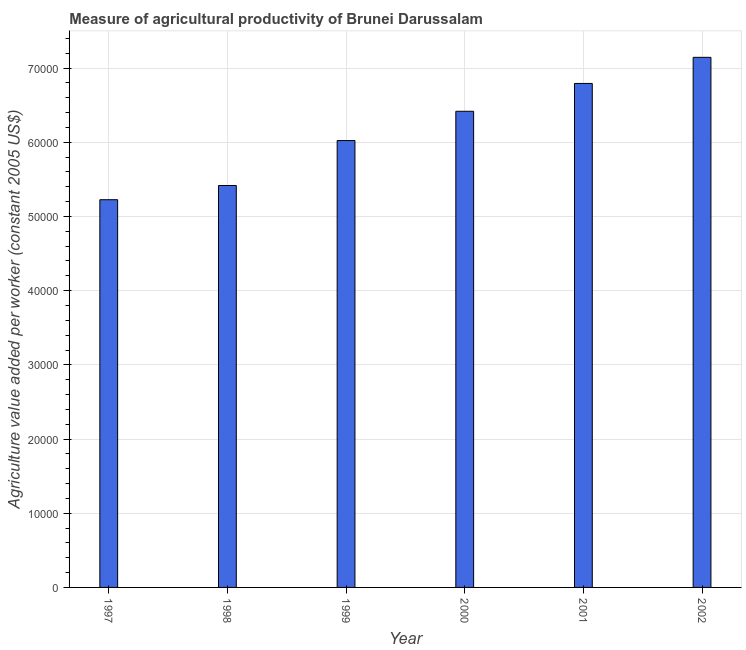Does the graph contain any zero values?
Offer a very short reply. No. Does the graph contain grids?
Your answer should be very brief. Yes. What is the title of the graph?
Provide a short and direct response. Measure of agricultural productivity of Brunei Darussalam. What is the label or title of the X-axis?
Offer a very short reply. Year. What is the label or title of the Y-axis?
Offer a terse response. Agriculture value added per worker (constant 2005 US$). What is the agriculture value added per worker in 1998?
Offer a terse response. 5.42e+04. Across all years, what is the maximum agriculture value added per worker?
Ensure brevity in your answer.  7.14e+04. Across all years, what is the minimum agriculture value added per worker?
Make the answer very short. 5.23e+04. In which year was the agriculture value added per worker maximum?
Provide a succinct answer. 2002. What is the sum of the agriculture value added per worker?
Ensure brevity in your answer.  3.70e+05. What is the difference between the agriculture value added per worker in 2000 and 2002?
Your answer should be very brief. -7270.42. What is the average agriculture value added per worker per year?
Your answer should be very brief. 6.17e+04. What is the median agriculture value added per worker?
Make the answer very short. 6.22e+04. Do a majority of the years between 1998 and 1997 (inclusive) have agriculture value added per worker greater than 4000 US$?
Provide a short and direct response. No. What is the ratio of the agriculture value added per worker in 1997 to that in 1999?
Offer a very short reply. 0.87. Is the difference between the agriculture value added per worker in 1998 and 2002 greater than the difference between any two years?
Provide a succinct answer. No. What is the difference between the highest and the second highest agriculture value added per worker?
Offer a terse response. 3518.98. Is the sum of the agriculture value added per worker in 1997 and 2000 greater than the maximum agriculture value added per worker across all years?
Your response must be concise. Yes. What is the difference between the highest and the lowest agriculture value added per worker?
Provide a succinct answer. 1.92e+04. How many bars are there?
Your response must be concise. 6. Are all the bars in the graph horizontal?
Offer a very short reply. No. How many years are there in the graph?
Ensure brevity in your answer.  6. What is the difference between two consecutive major ticks on the Y-axis?
Make the answer very short. 10000. Are the values on the major ticks of Y-axis written in scientific E-notation?
Make the answer very short. No. What is the Agriculture value added per worker (constant 2005 US$) in 1997?
Give a very brief answer. 5.23e+04. What is the Agriculture value added per worker (constant 2005 US$) in 1998?
Ensure brevity in your answer.  5.42e+04. What is the Agriculture value added per worker (constant 2005 US$) in 1999?
Your answer should be compact. 6.02e+04. What is the Agriculture value added per worker (constant 2005 US$) in 2000?
Keep it short and to the point. 6.42e+04. What is the Agriculture value added per worker (constant 2005 US$) of 2001?
Provide a short and direct response. 6.79e+04. What is the Agriculture value added per worker (constant 2005 US$) of 2002?
Offer a very short reply. 7.14e+04. What is the difference between the Agriculture value added per worker (constant 2005 US$) in 1997 and 1998?
Provide a succinct answer. -1916.66. What is the difference between the Agriculture value added per worker (constant 2005 US$) in 1997 and 1999?
Provide a short and direct response. -7969.64. What is the difference between the Agriculture value added per worker (constant 2005 US$) in 1997 and 2000?
Make the answer very short. -1.19e+04. What is the difference between the Agriculture value added per worker (constant 2005 US$) in 1997 and 2001?
Provide a succinct answer. -1.57e+04. What is the difference between the Agriculture value added per worker (constant 2005 US$) in 1997 and 2002?
Ensure brevity in your answer.  -1.92e+04. What is the difference between the Agriculture value added per worker (constant 2005 US$) in 1998 and 1999?
Make the answer very short. -6052.98. What is the difference between the Agriculture value added per worker (constant 2005 US$) in 1998 and 2000?
Give a very brief answer. -1.00e+04. What is the difference between the Agriculture value added per worker (constant 2005 US$) in 1998 and 2001?
Make the answer very short. -1.38e+04. What is the difference between the Agriculture value added per worker (constant 2005 US$) in 1998 and 2002?
Your answer should be compact. -1.73e+04. What is the difference between the Agriculture value added per worker (constant 2005 US$) in 1999 and 2000?
Provide a succinct answer. -3950. What is the difference between the Agriculture value added per worker (constant 2005 US$) in 1999 and 2001?
Make the answer very short. -7701.45. What is the difference between the Agriculture value added per worker (constant 2005 US$) in 1999 and 2002?
Your answer should be compact. -1.12e+04. What is the difference between the Agriculture value added per worker (constant 2005 US$) in 2000 and 2001?
Offer a terse response. -3751.45. What is the difference between the Agriculture value added per worker (constant 2005 US$) in 2000 and 2002?
Offer a very short reply. -7270.42. What is the difference between the Agriculture value added per worker (constant 2005 US$) in 2001 and 2002?
Provide a succinct answer. -3518.98. What is the ratio of the Agriculture value added per worker (constant 2005 US$) in 1997 to that in 1999?
Your answer should be very brief. 0.87. What is the ratio of the Agriculture value added per worker (constant 2005 US$) in 1997 to that in 2000?
Your response must be concise. 0.81. What is the ratio of the Agriculture value added per worker (constant 2005 US$) in 1997 to that in 2001?
Give a very brief answer. 0.77. What is the ratio of the Agriculture value added per worker (constant 2005 US$) in 1997 to that in 2002?
Offer a very short reply. 0.73. What is the ratio of the Agriculture value added per worker (constant 2005 US$) in 1998 to that in 1999?
Your answer should be compact. 0.9. What is the ratio of the Agriculture value added per worker (constant 2005 US$) in 1998 to that in 2000?
Make the answer very short. 0.84. What is the ratio of the Agriculture value added per worker (constant 2005 US$) in 1998 to that in 2001?
Offer a very short reply. 0.8. What is the ratio of the Agriculture value added per worker (constant 2005 US$) in 1998 to that in 2002?
Offer a very short reply. 0.76. What is the ratio of the Agriculture value added per worker (constant 2005 US$) in 1999 to that in 2000?
Ensure brevity in your answer.  0.94. What is the ratio of the Agriculture value added per worker (constant 2005 US$) in 1999 to that in 2001?
Provide a succinct answer. 0.89. What is the ratio of the Agriculture value added per worker (constant 2005 US$) in 1999 to that in 2002?
Provide a short and direct response. 0.84. What is the ratio of the Agriculture value added per worker (constant 2005 US$) in 2000 to that in 2001?
Ensure brevity in your answer.  0.94. What is the ratio of the Agriculture value added per worker (constant 2005 US$) in 2000 to that in 2002?
Your answer should be compact. 0.9. What is the ratio of the Agriculture value added per worker (constant 2005 US$) in 2001 to that in 2002?
Make the answer very short. 0.95. 